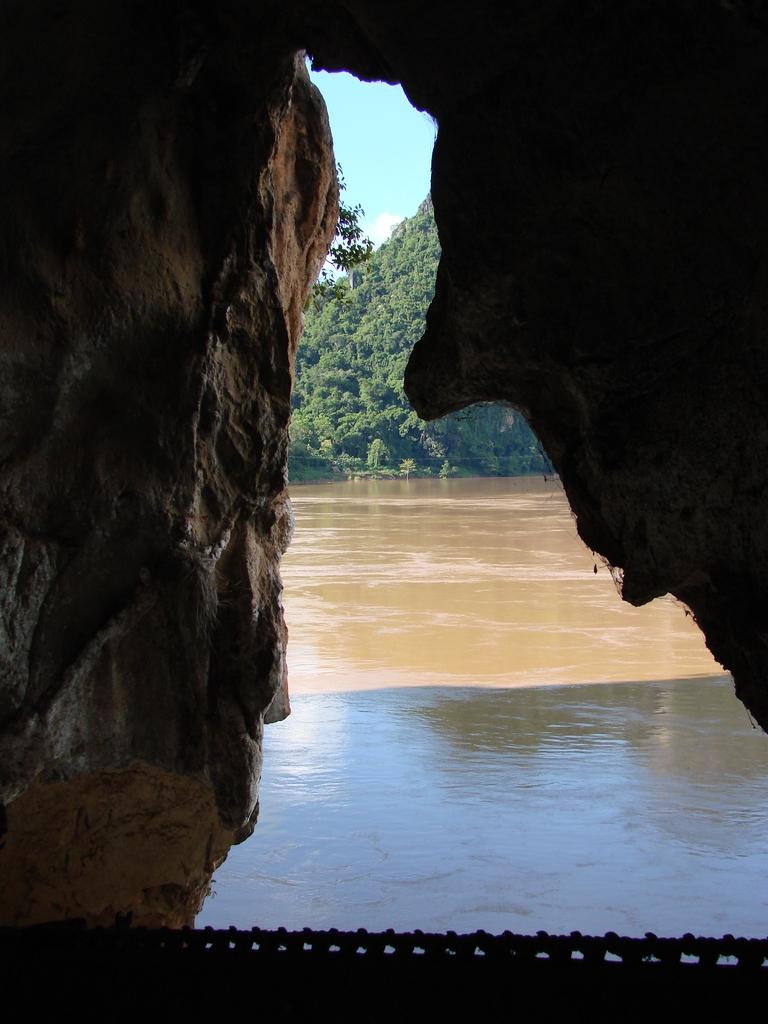What type of natural elements can be seen in the image? Rocks, a water flow, and trees can be seen in the image. Can you describe the water flow in the image? There is a water flow in the image. What type of vegetation is present in the image? Trees are present in the image. How does the beginner learn to kick in the image? There is no indication of anyone learning to kick in the image; it features rocks, a water flow, and trees. What type of current can be seen in the water flow in the image? There is no reference to a current in the water flow in the image; it simply shows a water flow. 